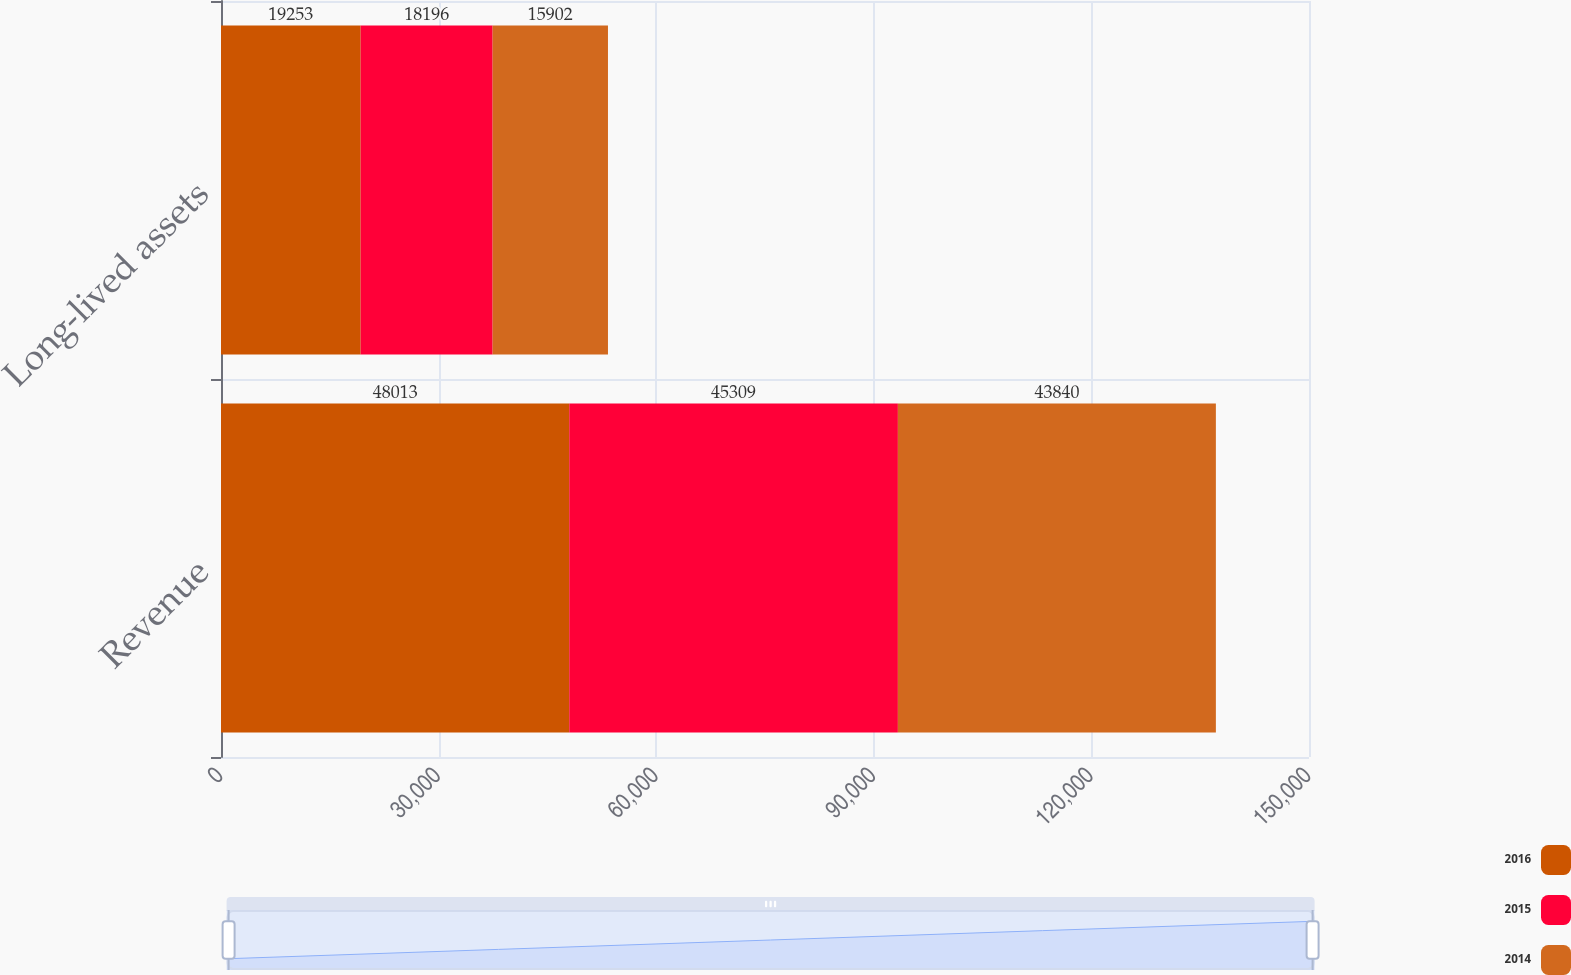<chart> <loc_0><loc_0><loc_500><loc_500><stacked_bar_chart><ecel><fcel>Revenue<fcel>Long-lived assets<nl><fcel>2016<fcel>48013<fcel>19253<nl><fcel>2015<fcel>45309<fcel>18196<nl><fcel>2014<fcel>43840<fcel>15902<nl></chart> 